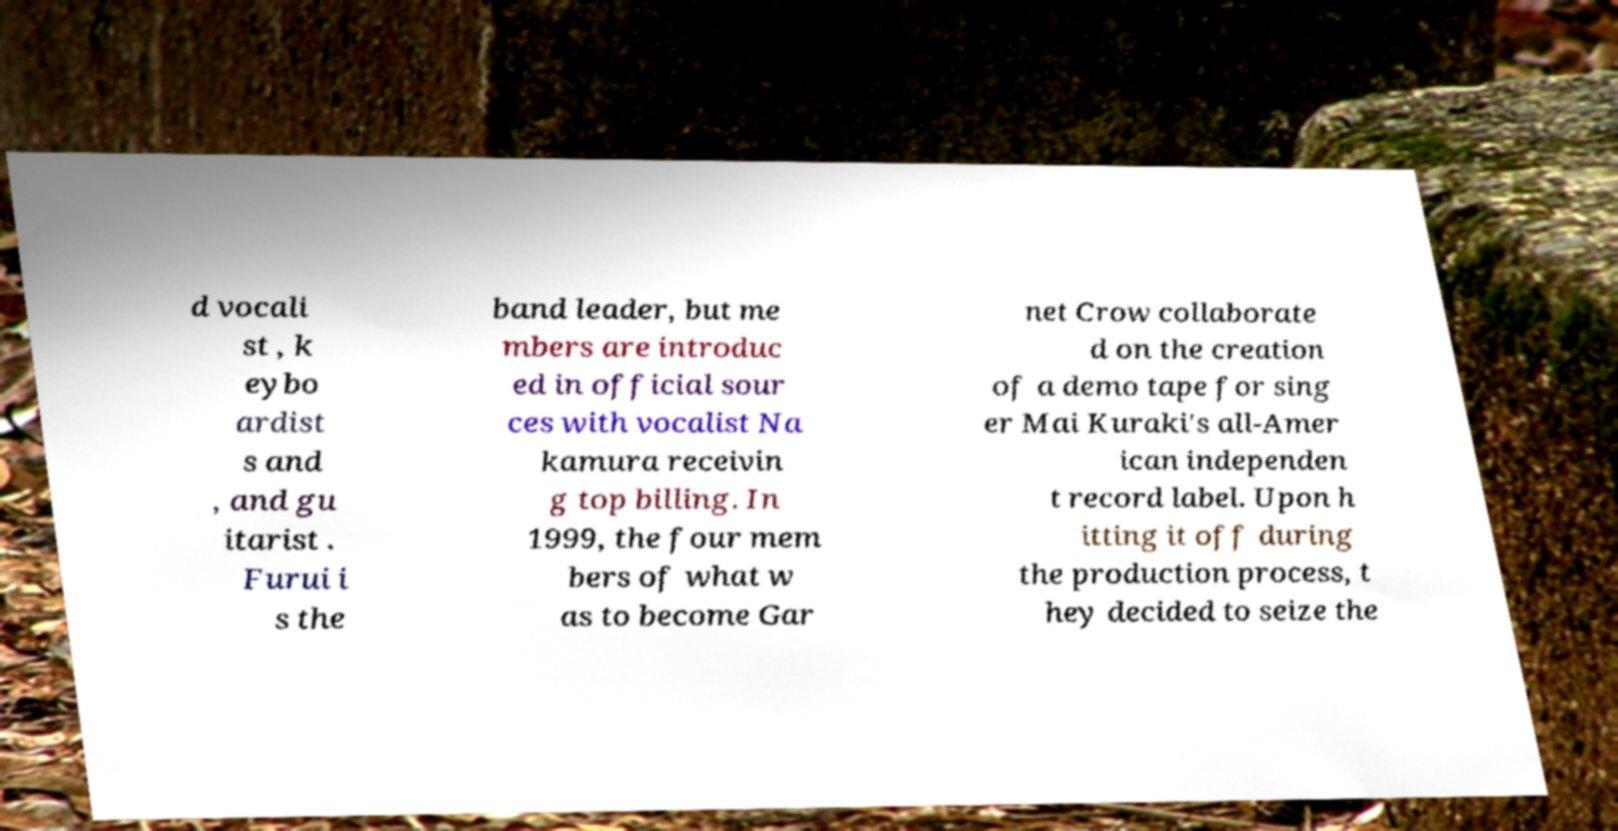I need the written content from this picture converted into text. Can you do that? d vocali st , k eybo ardist s and , and gu itarist . Furui i s the band leader, but me mbers are introduc ed in official sour ces with vocalist Na kamura receivin g top billing. In 1999, the four mem bers of what w as to become Gar net Crow collaborate d on the creation of a demo tape for sing er Mai Kuraki's all-Amer ican independen t record label. Upon h itting it off during the production process, t hey decided to seize the 